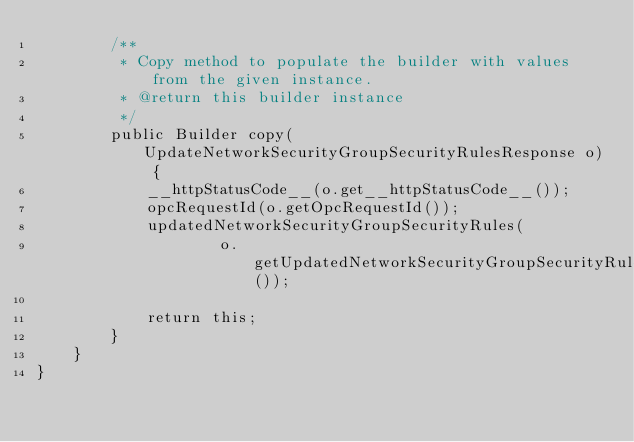<code> <loc_0><loc_0><loc_500><loc_500><_Java_>        /**
         * Copy method to populate the builder with values from the given instance.
         * @return this builder instance
         */
        public Builder copy(UpdateNetworkSecurityGroupSecurityRulesResponse o) {
            __httpStatusCode__(o.get__httpStatusCode__());
            opcRequestId(o.getOpcRequestId());
            updatedNetworkSecurityGroupSecurityRules(
                    o.getUpdatedNetworkSecurityGroupSecurityRules());

            return this;
        }
    }
}
</code> 